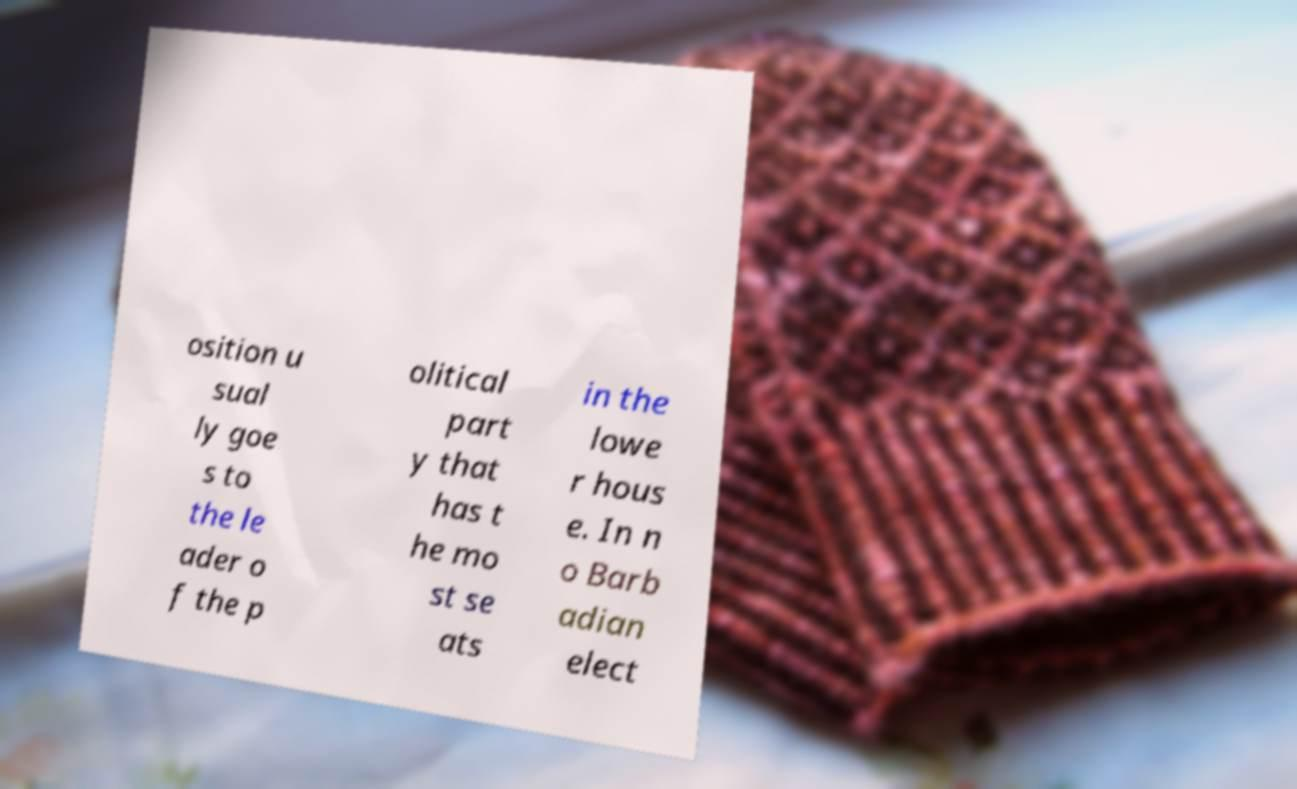Could you extract and type out the text from this image? osition u sual ly goe s to the le ader o f the p olitical part y that has t he mo st se ats in the lowe r hous e. In n o Barb adian elect 